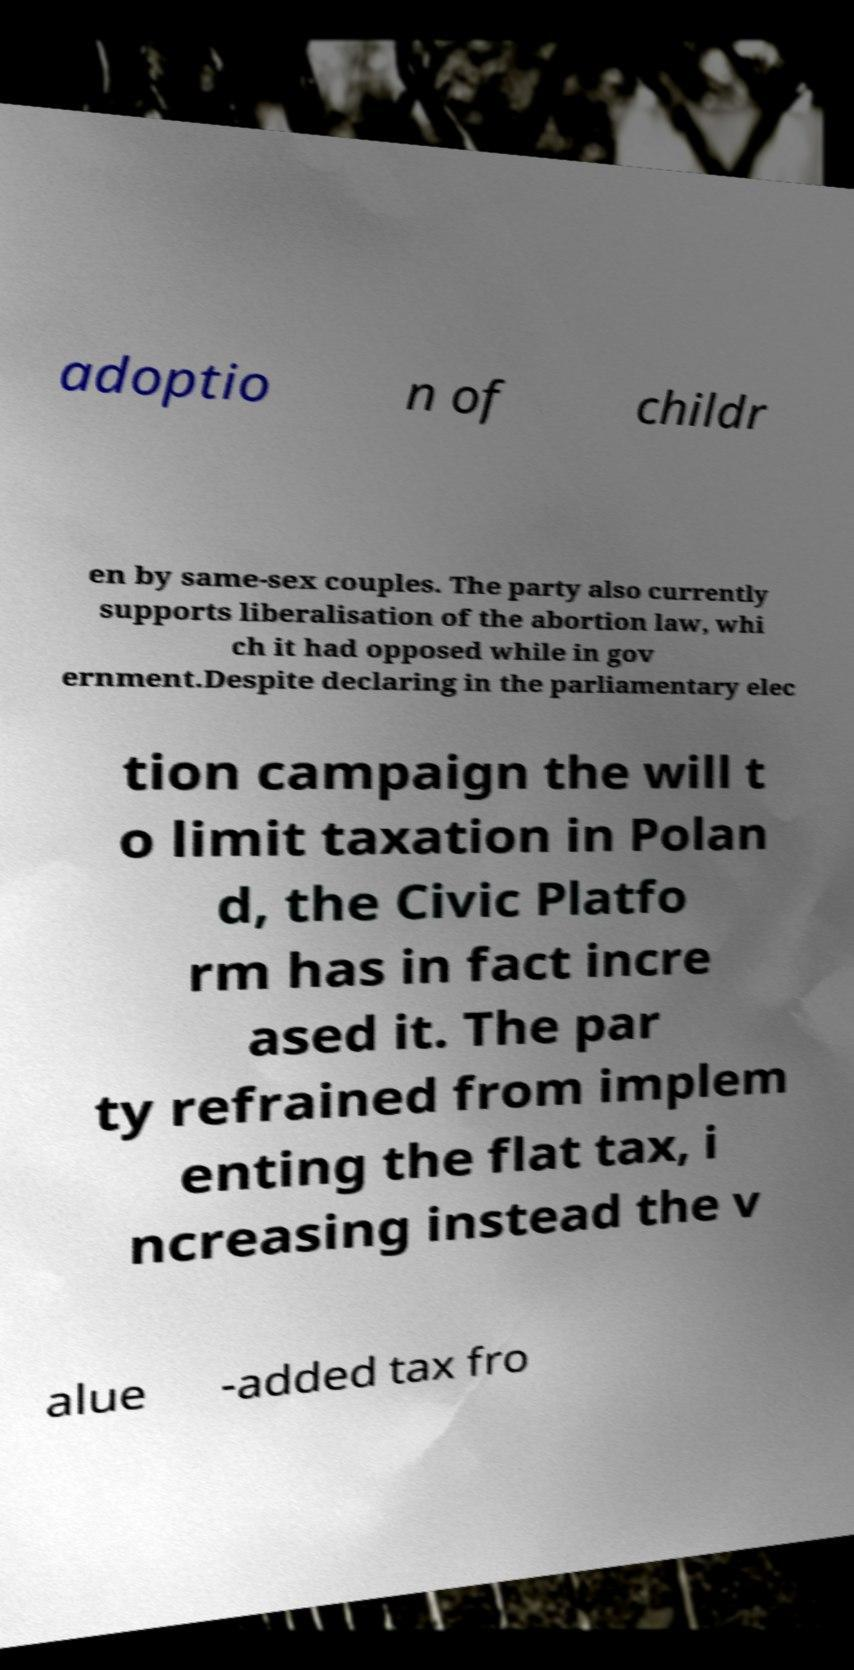Can you accurately transcribe the text from the provided image for me? adoptio n of childr en by same-sex couples. The party also currently supports liberalisation of the abortion law, whi ch it had opposed while in gov ernment.Despite declaring in the parliamentary elec tion campaign the will t o limit taxation in Polan d, the Civic Platfo rm has in fact incre ased it. The par ty refrained from implem enting the flat tax, i ncreasing instead the v alue -added tax fro 